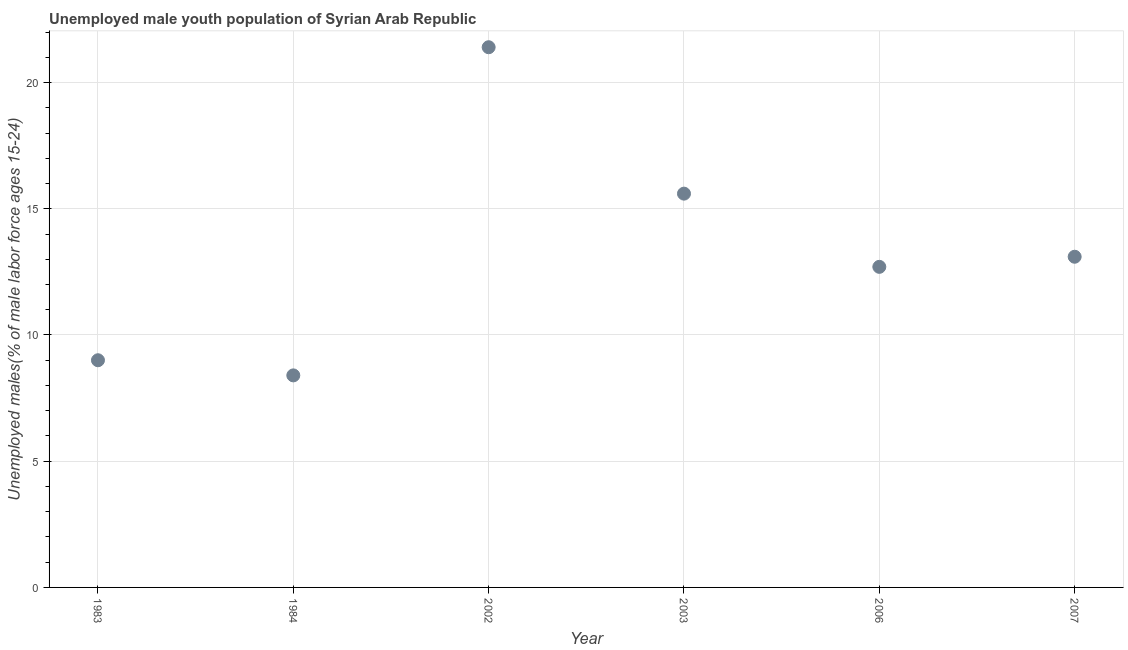What is the unemployed male youth in 2002?
Offer a terse response. 21.4. Across all years, what is the maximum unemployed male youth?
Your response must be concise. 21.4. Across all years, what is the minimum unemployed male youth?
Your response must be concise. 8.4. What is the sum of the unemployed male youth?
Make the answer very short. 80.2. What is the difference between the unemployed male youth in 1983 and 2006?
Ensure brevity in your answer.  -3.7. What is the average unemployed male youth per year?
Provide a succinct answer. 13.37. What is the median unemployed male youth?
Provide a short and direct response. 12.9. Do a majority of the years between 2007 and 2006 (inclusive) have unemployed male youth greater than 18 %?
Offer a terse response. No. What is the ratio of the unemployed male youth in 1983 to that in 2003?
Provide a succinct answer. 0.58. Is the unemployed male youth in 1984 less than that in 2006?
Your answer should be very brief. Yes. Is the difference between the unemployed male youth in 1983 and 2002 greater than the difference between any two years?
Ensure brevity in your answer.  No. What is the difference between the highest and the second highest unemployed male youth?
Your answer should be compact. 5.8. Is the sum of the unemployed male youth in 1983 and 2007 greater than the maximum unemployed male youth across all years?
Your answer should be compact. Yes. What is the difference between the highest and the lowest unemployed male youth?
Provide a short and direct response. 13. Does the unemployed male youth monotonically increase over the years?
Offer a very short reply. No. What is the difference between two consecutive major ticks on the Y-axis?
Keep it short and to the point. 5. Does the graph contain any zero values?
Give a very brief answer. No. Does the graph contain grids?
Provide a succinct answer. Yes. What is the title of the graph?
Provide a succinct answer. Unemployed male youth population of Syrian Arab Republic. What is the label or title of the X-axis?
Keep it short and to the point. Year. What is the label or title of the Y-axis?
Keep it short and to the point. Unemployed males(% of male labor force ages 15-24). What is the Unemployed males(% of male labor force ages 15-24) in 1984?
Your answer should be very brief. 8.4. What is the Unemployed males(% of male labor force ages 15-24) in 2002?
Your answer should be compact. 21.4. What is the Unemployed males(% of male labor force ages 15-24) in 2003?
Provide a succinct answer. 15.6. What is the Unemployed males(% of male labor force ages 15-24) in 2006?
Provide a succinct answer. 12.7. What is the Unemployed males(% of male labor force ages 15-24) in 2007?
Your answer should be very brief. 13.1. What is the difference between the Unemployed males(% of male labor force ages 15-24) in 1983 and 1984?
Offer a terse response. 0.6. What is the difference between the Unemployed males(% of male labor force ages 15-24) in 1983 and 2002?
Provide a short and direct response. -12.4. What is the difference between the Unemployed males(% of male labor force ages 15-24) in 1983 and 2003?
Make the answer very short. -6.6. What is the difference between the Unemployed males(% of male labor force ages 15-24) in 1983 and 2006?
Ensure brevity in your answer.  -3.7. What is the difference between the Unemployed males(% of male labor force ages 15-24) in 1984 and 2002?
Ensure brevity in your answer.  -13. What is the difference between the Unemployed males(% of male labor force ages 15-24) in 2002 and 2007?
Offer a very short reply. 8.3. What is the difference between the Unemployed males(% of male labor force ages 15-24) in 2003 and 2006?
Provide a short and direct response. 2.9. What is the difference between the Unemployed males(% of male labor force ages 15-24) in 2006 and 2007?
Provide a succinct answer. -0.4. What is the ratio of the Unemployed males(% of male labor force ages 15-24) in 1983 to that in 1984?
Your answer should be compact. 1.07. What is the ratio of the Unemployed males(% of male labor force ages 15-24) in 1983 to that in 2002?
Offer a terse response. 0.42. What is the ratio of the Unemployed males(% of male labor force ages 15-24) in 1983 to that in 2003?
Offer a very short reply. 0.58. What is the ratio of the Unemployed males(% of male labor force ages 15-24) in 1983 to that in 2006?
Give a very brief answer. 0.71. What is the ratio of the Unemployed males(% of male labor force ages 15-24) in 1983 to that in 2007?
Provide a succinct answer. 0.69. What is the ratio of the Unemployed males(% of male labor force ages 15-24) in 1984 to that in 2002?
Offer a terse response. 0.39. What is the ratio of the Unemployed males(% of male labor force ages 15-24) in 1984 to that in 2003?
Keep it short and to the point. 0.54. What is the ratio of the Unemployed males(% of male labor force ages 15-24) in 1984 to that in 2006?
Offer a terse response. 0.66. What is the ratio of the Unemployed males(% of male labor force ages 15-24) in 1984 to that in 2007?
Keep it short and to the point. 0.64. What is the ratio of the Unemployed males(% of male labor force ages 15-24) in 2002 to that in 2003?
Offer a terse response. 1.37. What is the ratio of the Unemployed males(% of male labor force ages 15-24) in 2002 to that in 2006?
Keep it short and to the point. 1.69. What is the ratio of the Unemployed males(% of male labor force ages 15-24) in 2002 to that in 2007?
Make the answer very short. 1.63. What is the ratio of the Unemployed males(% of male labor force ages 15-24) in 2003 to that in 2006?
Your response must be concise. 1.23. What is the ratio of the Unemployed males(% of male labor force ages 15-24) in 2003 to that in 2007?
Offer a terse response. 1.19. What is the ratio of the Unemployed males(% of male labor force ages 15-24) in 2006 to that in 2007?
Your answer should be very brief. 0.97. 